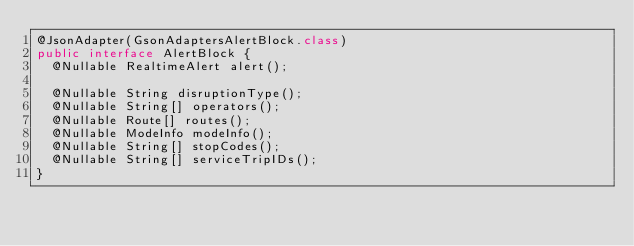<code> <loc_0><loc_0><loc_500><loc_500><_Java_>@JsonAdapter(GsonAdaptersAlertBlock.class)
public interface AlertBlock {
  @Nullable RealtimeAlert alert();

  @Nullable String disruptionType();
  @Nullable String[] operators();
  @Nullable Route[] routes();
  @Nullable ModeInfo modeInfo();
  @Nullable String[] stopCodes();
  @Nullable String[] serviceTripIDs();
}</code> 